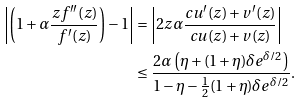Convert formula to latex. <formula><loc_0><loc_0><loc_500><loc_500>\left | \left ( 1 + \alpha \frac { z f ^ { \prime \prime } ( z ) } { f ^ { \prime } ( z ) } \right ) - 1 \right | & = \left | 2 z \alpha \frac { c u ^ { \prime } ( z ) + v ^ { \prime } ( z ) } { c u ( z ) + v ( z ) } \right | \\ & \leq \frac { 2 \alpha \left ( \eta + ( 1 + \eta ) \delta e ^ { \delta / 2 } \right ) } { 1 - \eta - \frac { 1 } { 2 } ( 1 + \eta ) \delta e ^ { \delta / 2 } } .</formula> 